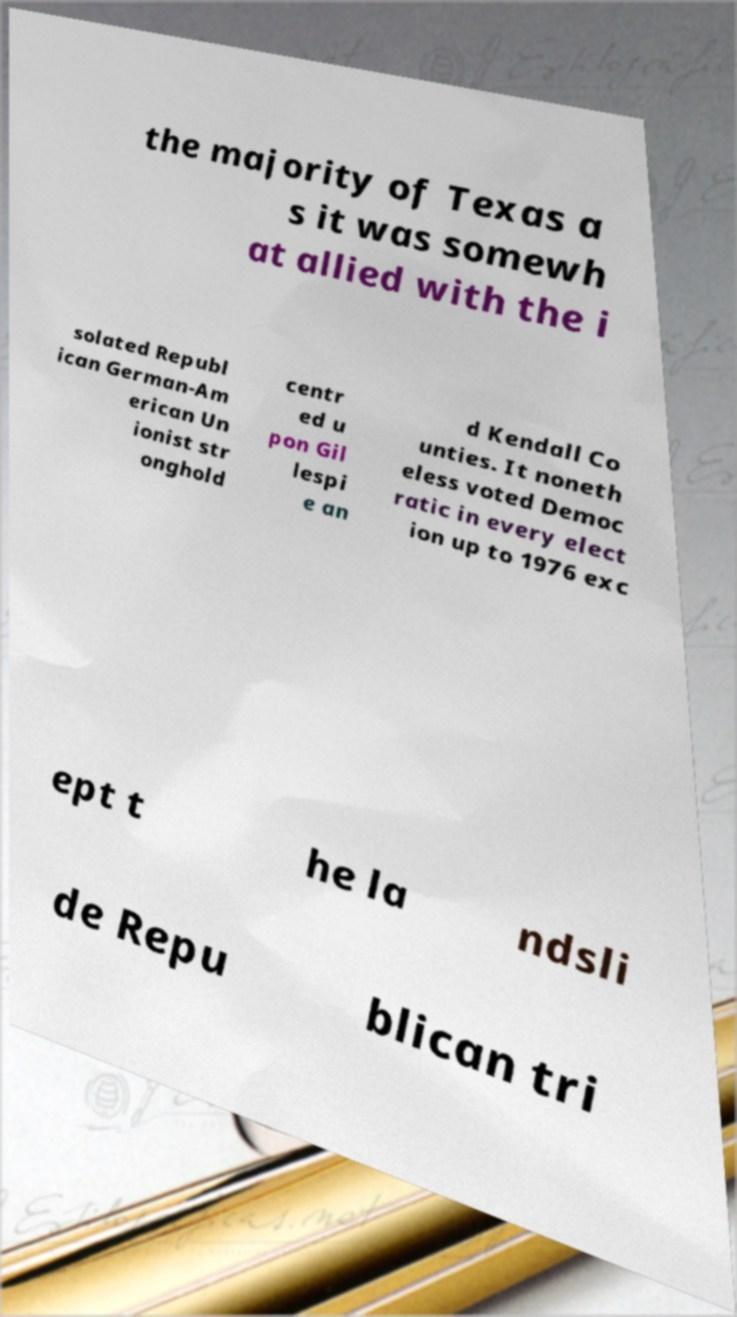There's text embedded in this image that I need extracted. Can you transcribe it verbatim? the majority of Texas a s it was somewh at allied with the i solated Republ ican German-Am erican Un ionist str onghold centr ed u pon Gil lespi e an d Kendall Co unties. It noneth eless voted Democ ratic in every elect ion up to 1976 exc ept t he la ndsli de Repu blican tri 